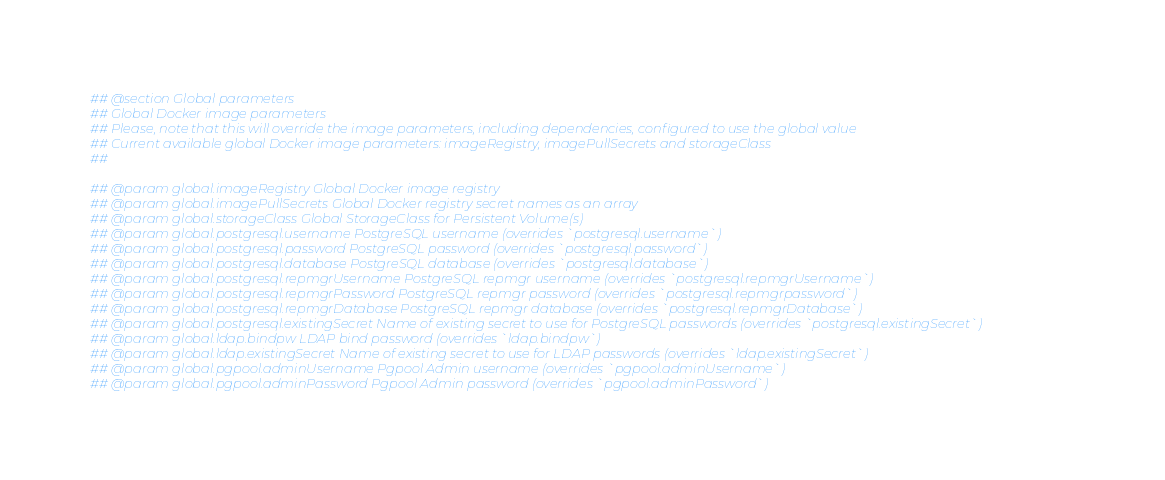<code> <loc_0><loc_0><loc_500><loc_500><_YAML_>## @section Global parameters
## Global Docker image parameters
## Please, note that this will override the image parameters, including dependencies, configured to use the global value
## Current available global Docker image parameters: imageRegistry, imagePullSecrets and storageClass
##

## @param global.imageRegistry Global Docker image registry
## @param global.imagePullSecrets Global Docker registry secret names as an array
## @param global.storageClass Global StorageClass for Persistent Volume(s)
## @param global.postgresql.username PostgreSQL username (overrides `postgresql.username`)
## @param global.postgresql.password PostgreSQL password (overrides `postgresql.password`)
## @param global.postgresql.database PostgreSQL database (overrides `postgresql.database`)
## @param global.postgresql.repmgrUsername PostgreSQL repmgr username (overrides `postgresql.repmgrUsername`)
## @param global.postgresql.repmgrPassword PostgreSQL repmgr password (overrides `postgresql.repmgrpassword`)
## @param global.postgresql.repmgrDatabase PostgreSQL repmgr database (overrides `postgresql.repmgrDatabase`)
## @param global.postgresql.existingSecret Name of existing secret to use for PostgreSQL passwords (overrides `postgresql.existingSecret`)
## @param global.ldap.bindpw LDAP bind password (overrides `ldap.bindpw`)
## @param global.ldap.existingSecret Name of existing secret to use for LDAP passwords (overrides `ldap.existingSecret`)
## @param global.pgpool.adminUsername Pgpool Admin username (overrides `pgpool.adminUsername`)
## @param global.pgpool.adminPassword Pgpool Admin password (overrides `pgpool.adminPassword`)</code> 